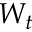<formula> <loc_0><loc_0><loc_500><loc_500>W _ { t }</formula> 